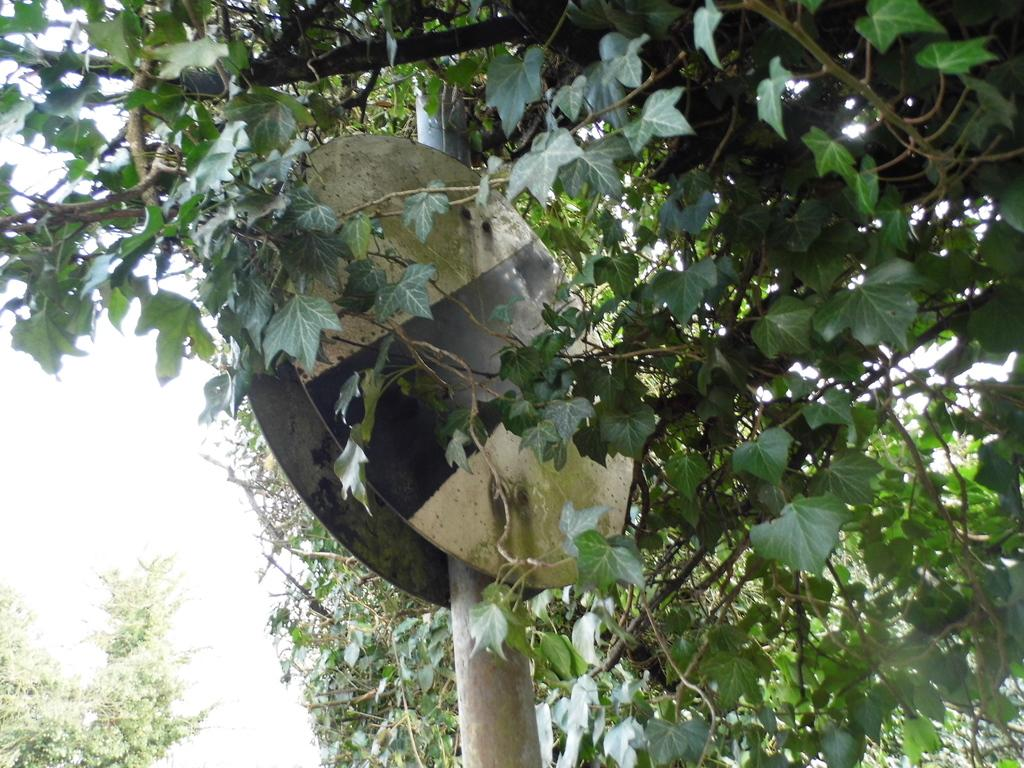What is the main object in the center of the image? There is a pole in the center of the image. What else can be seen in the center of the image? There are boards in the center of the image. What type of natural elements are present in the image? There are trees in the image. What can be seen in the background of the image? There are plants in the background of the image. What type of activity is taking place around the oven in the image? There is no oven present in the image, so no activity can be observed around it. 